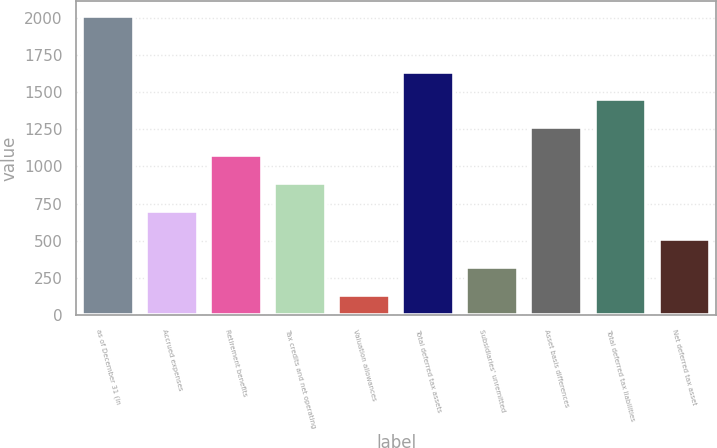Convert chart to OTSL. <chart><loc_0><loc_0><loc_500><loc_500><bar_chart><fcel>as of December 31 (in<fcel>Accrued expenses<fcel>Retirement benefits<fcel>Tax credits and net operating<fcel>Valuation allowances<fcel>Total deferred tax assets<fcel>Subsidiaries' unremitted<fcel>Asset basis differences<fcel>Total deferred tax liabilities<fcel>Net deferred tax asset<nl><fcel>2013<fcel>699.8<fcel>1075<fcel>887.4<fcel>137<fcel>1637.8<fcel>324.6<fcel>1262.6<fcel>1450.2<fcel>512.2<nl></chart> 